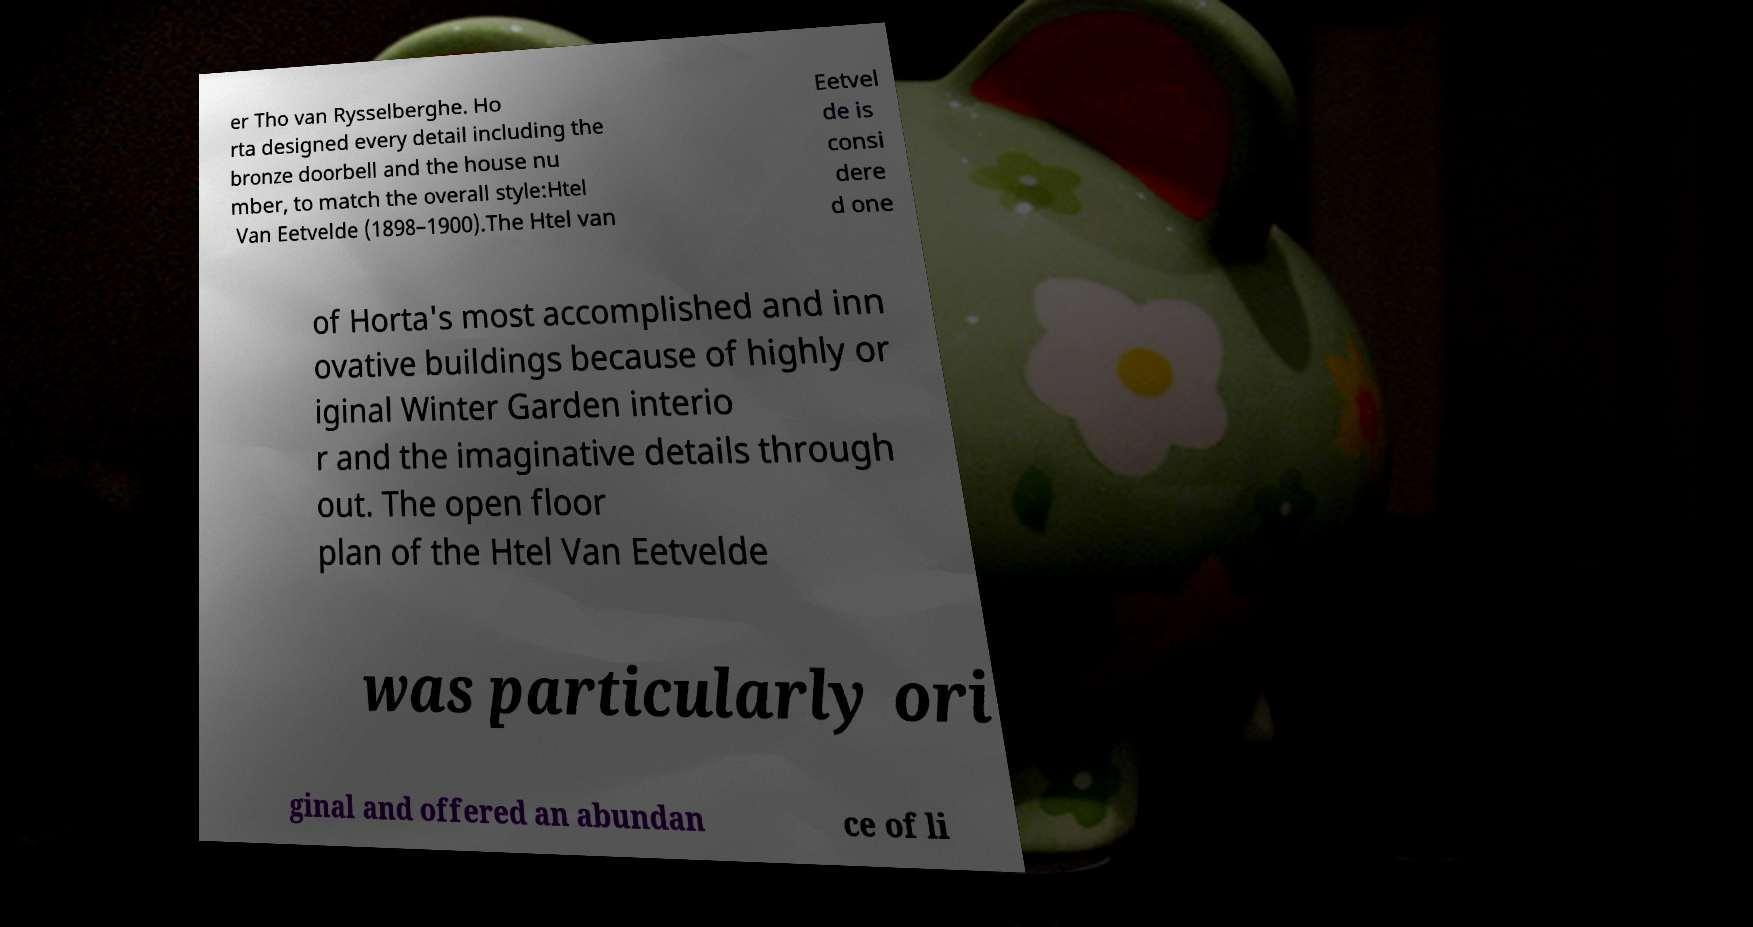For documentation purposes, I need the text within this image transcribed. Could you provide that? er Tho van Rysselberghe. Ho rta designed every detail including the bronze doorbell and the house nu mber, to match the overall style:Htel Van Eetvelde (1898–1900).The Htel van Eetvel de is consi dere d one of Horta's most accomplished and inn ovative buildings because of highly or iginal Winter Garden interio r and the imaginative details through out. The open floor plan of the Htel Van Eetvelde was particularly ori ginal and offered an abundan ce of li 